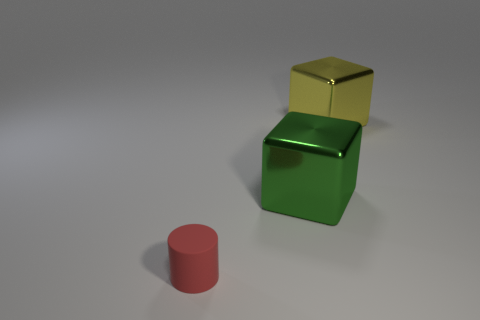Are the large cube behind the green metal block and the cube that is in front of the yellow cube made of the same material?
Offer a terse response. Yes. What is the shape of the shiny thing that is in front of the yellow metallic cube?
Ensure brevity in your answer.  Cube. How many things are red rubber cylinders or things that are in front of the green block?
Keep it short and to the point. 1. Do the green block and the red cylinder have the same material?
Your answer should be very brief. No. Are there an equal number of large yellow things that are to the right of the large green shiny block and metallic blocks that are in front of the small matte object?
Your response must be concise. No. What number of tiny red objects are in front of the yellow shiny cube?
Your answer should be compact. 1. What number of things are either small cyan rubber spheres or large green cubes?
Keep it short and to the point. 1. What number of yellow metal cubes have the same size as the red matte cylinder?
Your response must be concise. 0. What is the shape of the large thing to the right of the metal object that is on the left side of the yellow metallic object?
Ensure brevity in your answer.  Cube. Is the number of large blue things less than the number of big green metal things?
Ensure brevity in your answer.  Yes. 